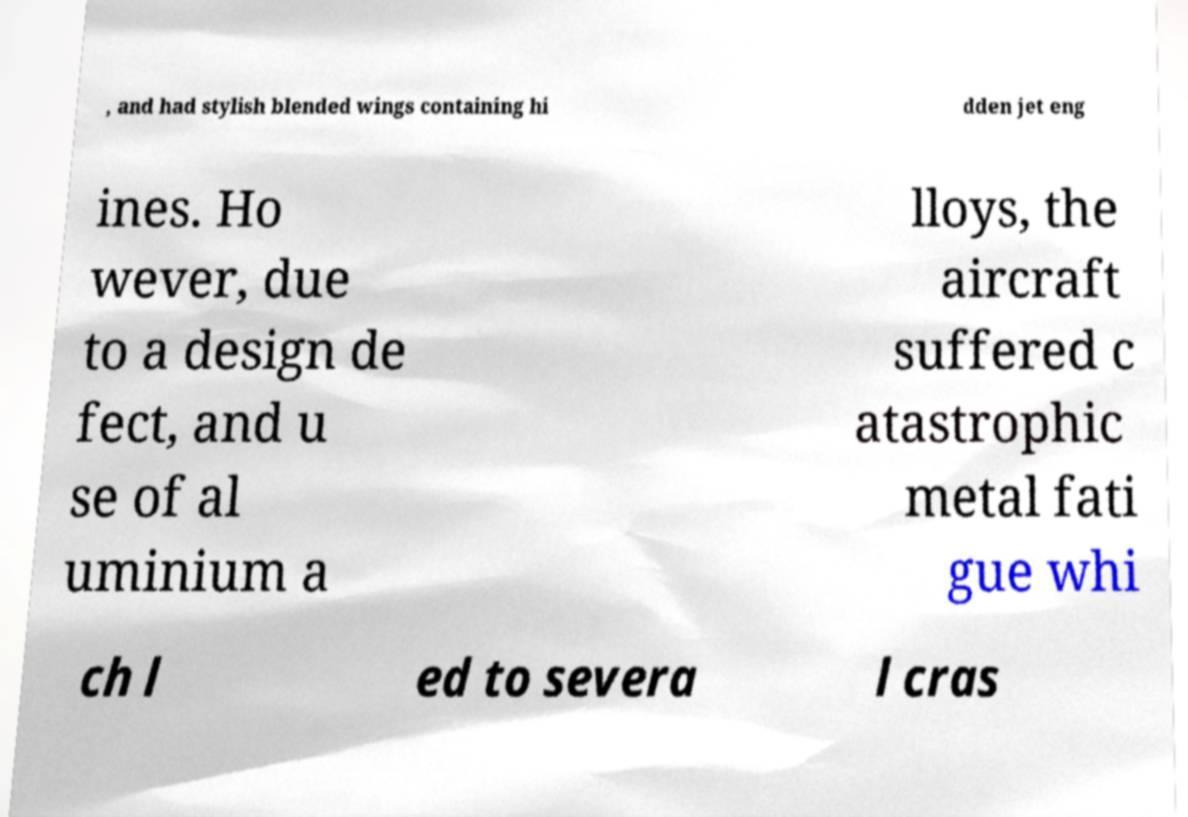I need the written content from this picture converted into text. Can you do that? , and had stylish blended wings containing hi dden jet eng ines. Ho wever, due to a design de fect, and u se of al uminium a lloys, the aircraft suffered c atastrophic metal fati gue whi ch l ed to severa l cras 